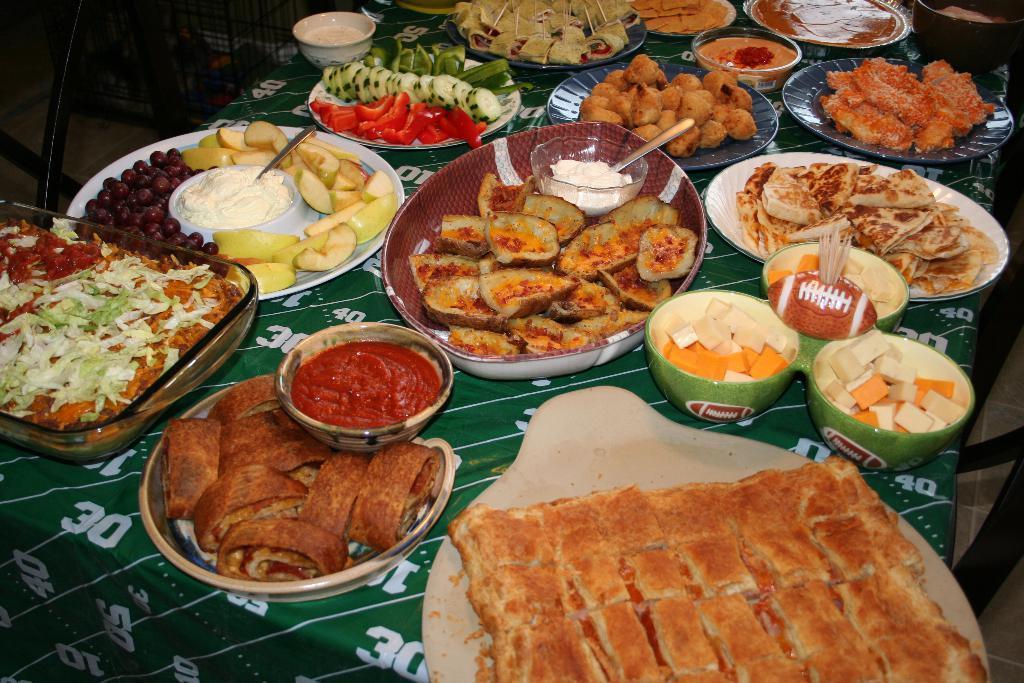Describe this image in one or two sentences. In this image we can see some food items in plates and bowls and all these are placed on a surface which looks like a table and there is a table cloth 